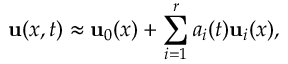Convert formula to latex. <formula><loc_0><loc_0><loc_500><loc_500>{ u } ( x , t ) \approx { u } _ { 0 } ( x ) + \sum _ { i = 1 } ^ { r } a _ { i } ( t ) { u } _ { i } ( x ) ,</formula> 